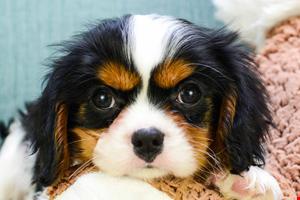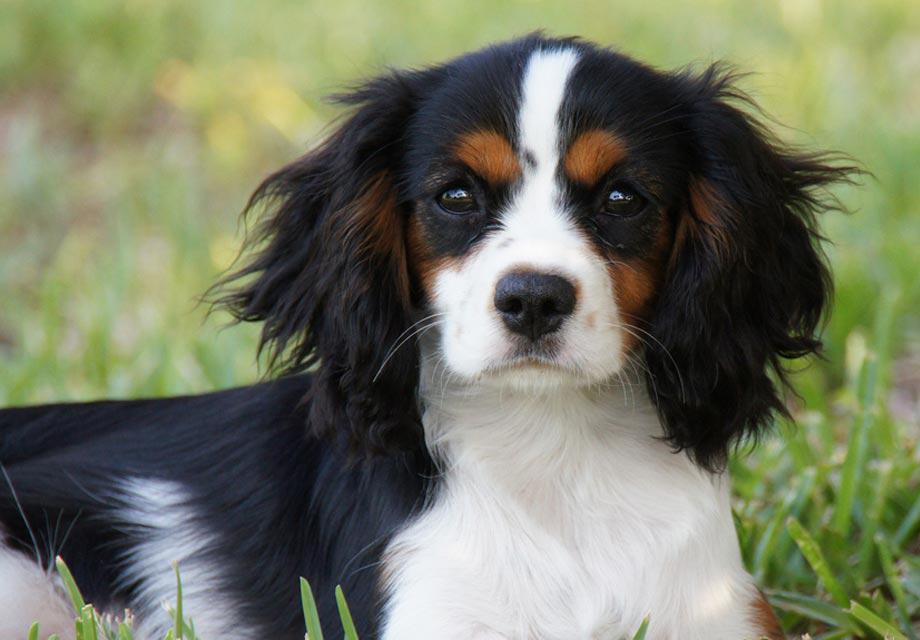The first image is the image on the left, the second image is the image on the right. Examine the images to the left and right. Is the description "There is at most 2 dogs." accurate? Answer yes or no. Yes. The first image is the image on the left, the second image is the image on the right. Considering the images on both sides, is "There is at least one image that shows exactly one dog in the grass." valid? Answer yes or no. Yes. 